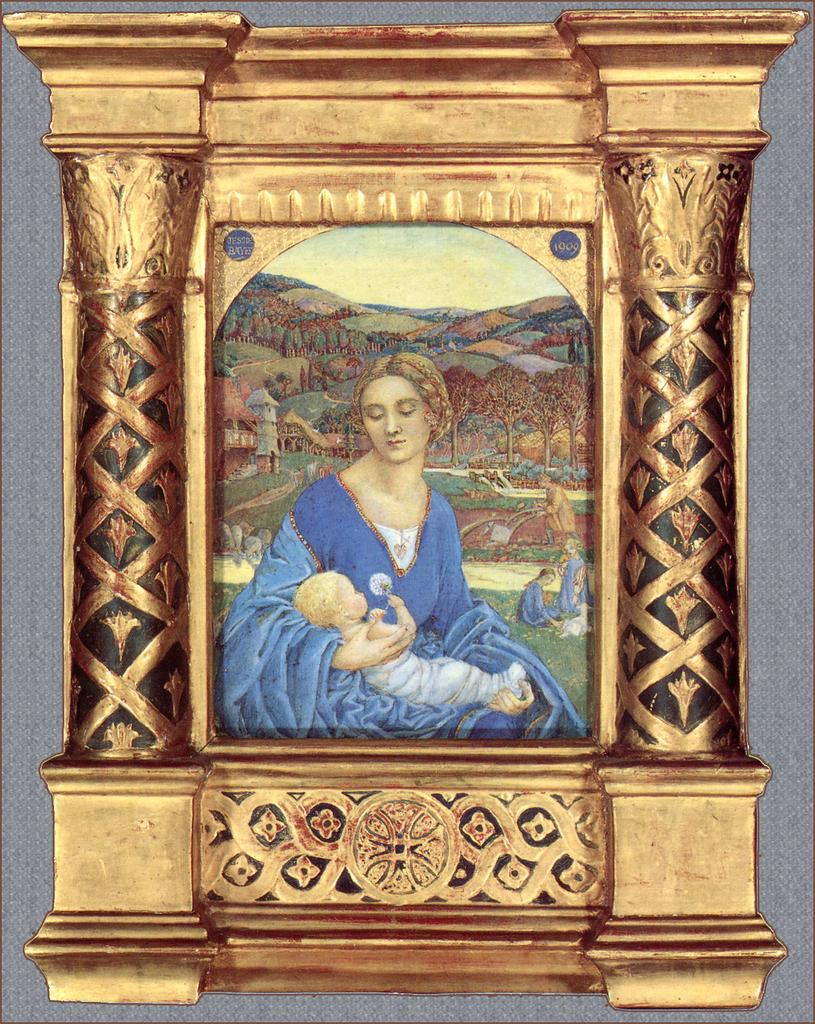What is hanging on the wall in the image? There is a photo frame on the wall in the image. What is inside the photo frame? The photo frame contains a painting. What does the painting depict? The painting depicts a few persons and many buildings. Where is the chair located in the image? There is no chair present in the image. What type of playground can be seen in the image? There is no playground present in the image. 